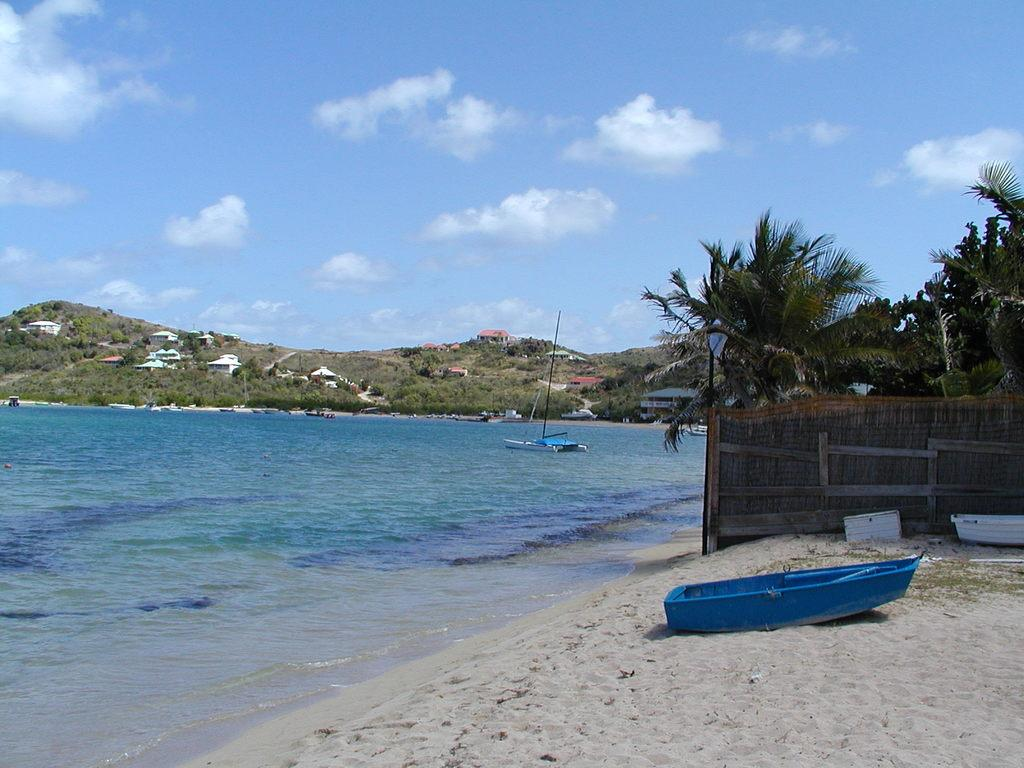What can be seen in the left corner of the image? There is water in the left corner of the image. What is located in the right corner of the image? There are trees and a fence wall in the right corner of the image. What is visible in the background of the image? Trees and buildings are visible in the background of the image. What type of game is being played by the uncle in the image? There is no uncle or game present in the image. What is the uncle holding in his hand in the image? There is no uncle or hand holding anything in the image. 